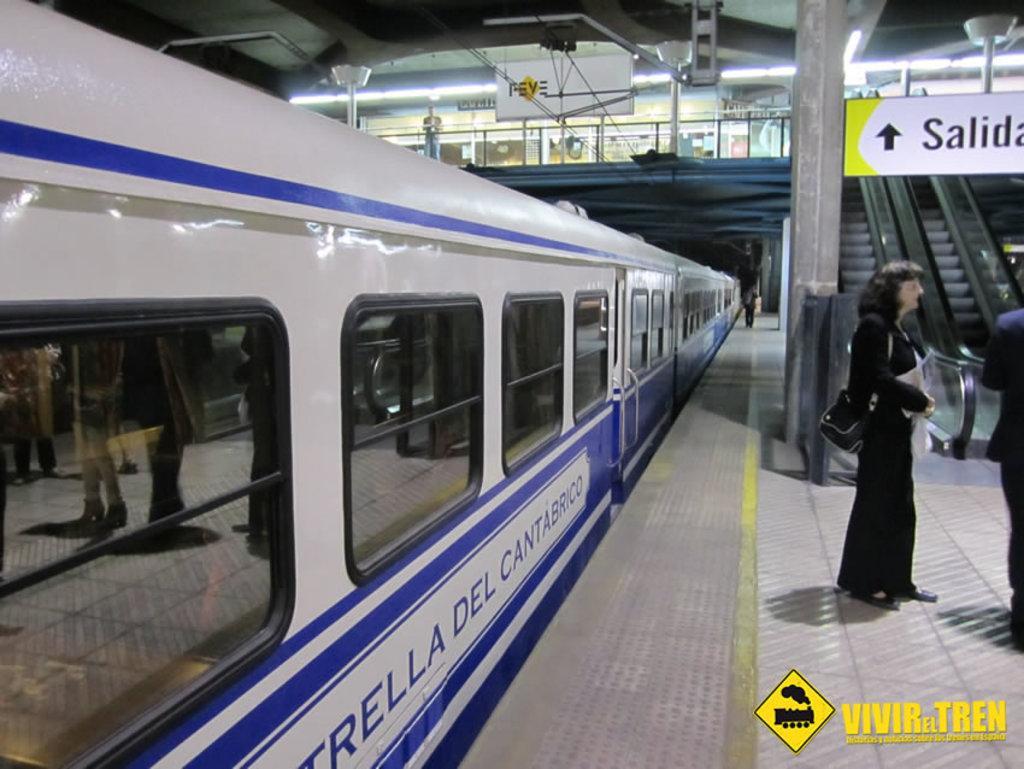Can you describe this image briefly? In this image, we can see train. There are two persons standing in front of the escalator. There is a board in the top right of the image. There is a person standing on foot over bridge which is at the top of the image. There is a text in the bottom right of the image. 